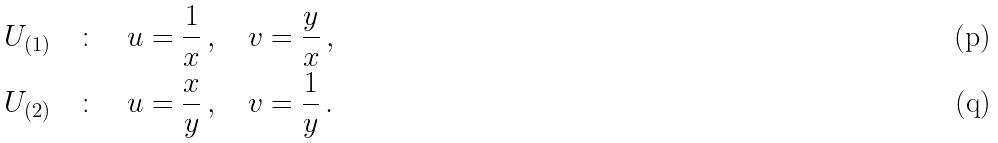<formula> <loc_0><loc_0><loc_500><loc_500>& U _ { ( 1 ) } \quad \colon \quad u = \frac { 1 } { x } \, , \quad v = \frac { y } { x } \, , \\ & U _ { ( 2 ) } \quad \colon \quad u = \frac { x } { y } \, , \quad v = \frac { 1 } { y } \, .</formula> 